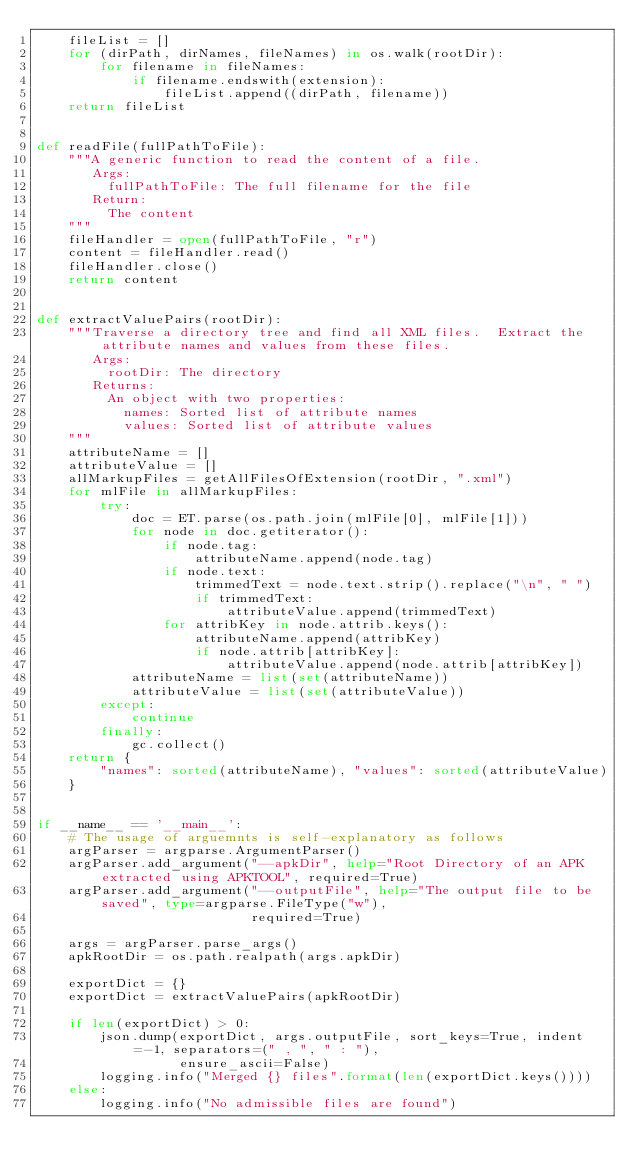Convert code to text. <code><loc_0><loc_0><loc_500><loc_500><_Python_>    fileList = []
    for (dirPath, dirNames, fileNames) in os.walk(rootDir):
        for filename in fileNames:
            if filename.endswith(extension):
                fileList.append((dirPath, filename))
    return fileList


def readFile(fullPathToFile):
    """A generic function to read the content of a file.
       Args:
         fullPathToFile: The full filename for the file
       Return:
         The content
    """
    fileHandler = open(fullPathToFile, "r")
    content = fileHandler.read()
    fileHandler.close()
    return content


def extractValuePairs(rootDir):
    """Traverse a directory tree and find all XML files.  Extract the attribute names and values from these files.
       Args:
         rootDir: The directory
       Returns:
         An object with two properties:
           names: Sorted list of attribute names 
           values: Sorted list of attribute values
    """
    attributeName = []
    attributeValue = []
    allMarkupFiles = getAllFilesOfExtension(rootDir, ".xml")
    for mlFile in allMarkupFiles:
        try:
            doc = ET.parse(os.path.join(mlFile[0], mlFile[1]))
            for node in doc.getiterator():
                if node.tag:
                    attributeName.append(node.tag)
                if node.text:
                    trimmedText = node.text.strip().replace("\n", " ")
                    if trimmedText:
                        attributeValue.append(trimmedText)
                for attribKey in node.attrib.keys():
                    attributeName.append(attribKey)
                    if node.attrib[attribKey]:
                        attributeValue.append(node.attrib[attribKey])
            attributeName = list(set(attributeName))
            attributeValue = list(set(attributeValue))
        except:
            continue
        finally:
            gc.collect()
    return {
        "names": sorted(attributeName), "values": sorted(attributeValue)
    }


if __name__ == '__main__':
    # The usage of arguemnts is self-explanatory as follows
    argParser = argparse.ArgumentParser()
    argParser.add_argument("--apkDir", help="Root Directory of an APK extracted using APKTOOL", required=True)
    argParser.add_argument("--outputFile", help="The output file to be saved", type=argparse.FileType("w"),
                           required=True)

    args = argParser.parse_args()
    apkRootDir = os.path.realpath(args.apkDir)

    exportDict = {}
    exportDict = extractValuePairs(apkRootDir)

    if len(exportDict) > 0:
        json.dump(exportDict, args.outputFile, sort_keys=True, indent=-1, separators=(" , ", " : "),
                  ensure_ascii=False)
        logging.info("Merged {} files".format(len(exportDict.keys())))
    else:
        logging.info("No admissible files are found")
</code> 